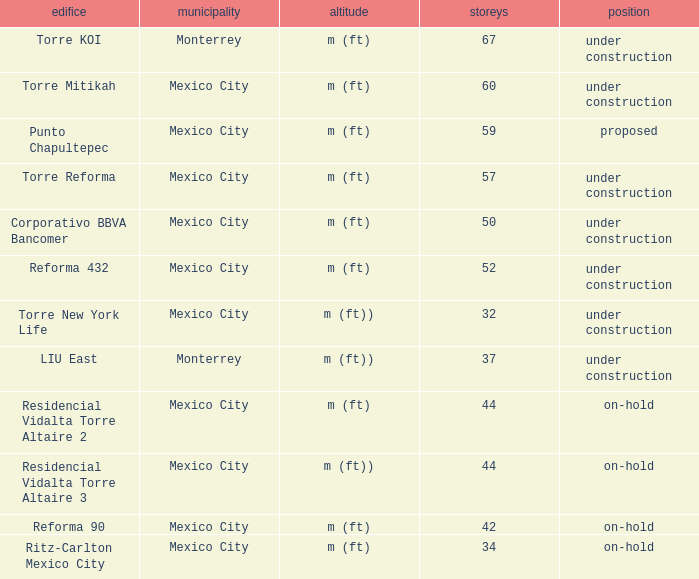How tall is the 52 story building? M (ft). 